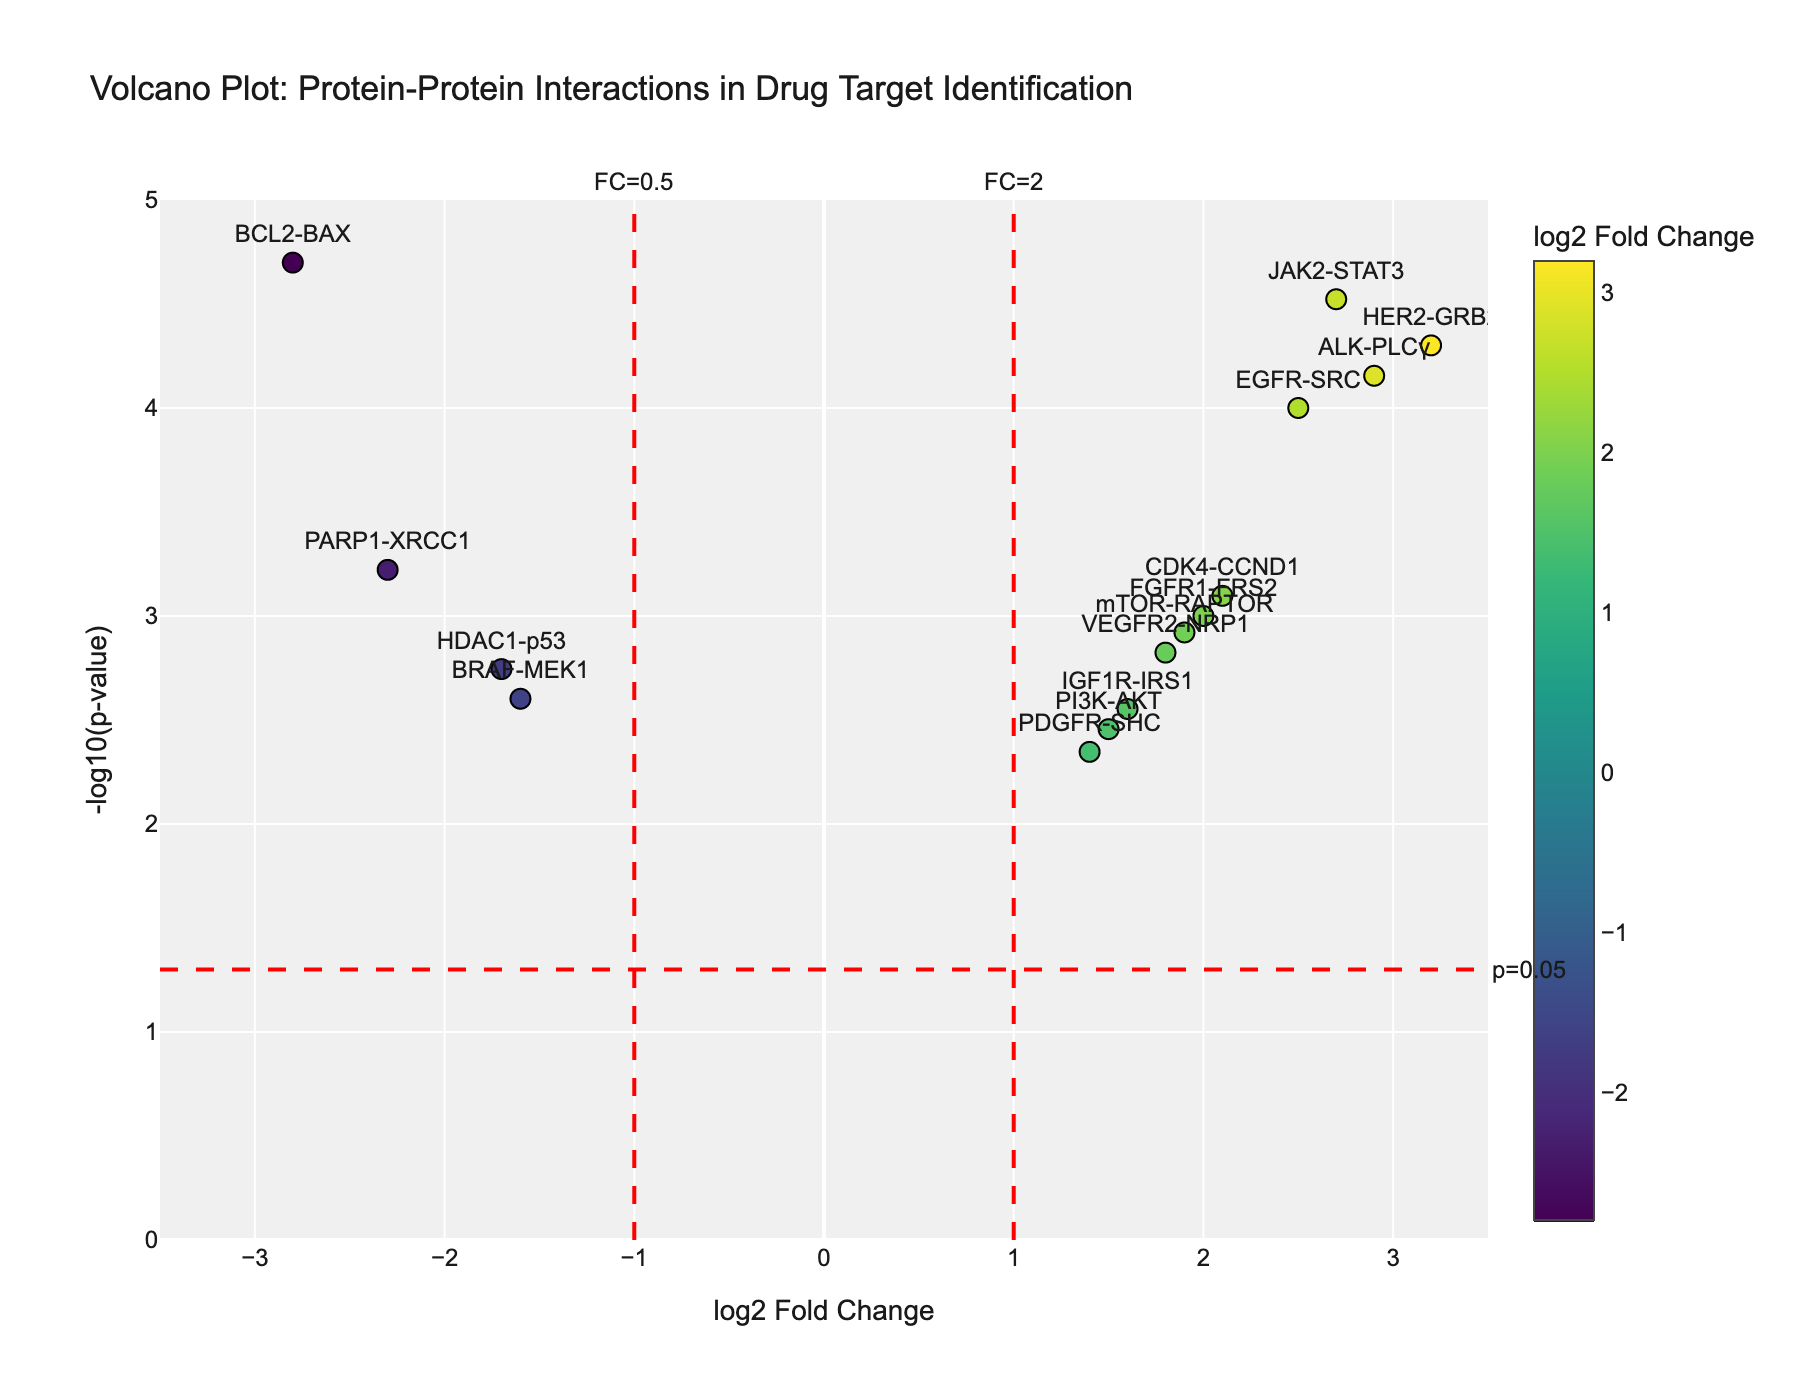How many protein-protein interactions are plotted on the Volcano Plot? By counting the number of data points (markers) on the plot, you can determine the number of protein-protein interactions.
Answer: 14 Which protein interaction has the highest log2 Fold Change? Identify the data point with the highest x-axis value, which represents log2 Fold Change. According to the dataset, HER2-GRB2 has the highest log2 Fold Change of 3.2.
Answer: HER2-GRB2 What is the p-value for the interaction between EGFR and SRC? Use the hover information of the data point associated with EGFR-SRC to find the p-value provided there. The p-value for EGFR-SRC interaction is 0.0001.
Answer: 0.0001 Among the plotted interactions, which one has the most significant p-value (i.e., the smallest p-value)? Identify the data point with the highest y-axis value, which represents the -log10(pValue). The interaction JAK2-STAT3 has the most significant p-value, as indicated by its highest position on the y-axis.
Answer: JAK2-STAT3 Compare the log2 Fold Change between the BRAF-MEK1 and PARP1-XRCC1 interactions. Which is more negative? Locate the x-axis values (log2 Fold Change) for BRAF-MEK1 and PARP1-XRCC1 and compare them. BRAF-MEK1 has a log2 Fold Change of -1.6 and PARP1-XRCC1 has -2.3, so PARP1-XRCC1 is more negative.
Answer: PARP1-XRCC1 How many interactions have a log2 Fold Change greater than 2 and a p-value less than 0.001? Identify the data points that fall to the right of the vertical line at x=2 and above the horizontal line at y=-log10(0.001). These interactions are HER2-GRB2, JAK2-STAT3, and ALK-PLCγ, totaling 3 interactions.
Answer: 3 Are there any interactions with a log2 Fold Change less than -2? If so, name them. Identify data points with x-axis values less than -2. The one such interaction is BCL2-BAX with a log2 Fold Change of -2.8.
Answer: BCL2-BAX What is the approximate range of -log10(p-values) on the y-axis? Determine the lowest and highest y-axis values represented by the data points. The range is from approximately 0 (for higher p-values) to about 5 (for the most significant p-values).
Answer: 0 to 5 Which interaction has a log2 Fold Change closest to 2.0 with a significant p-value? Identify the data point with an x-axis value closest to 2.0 and verify if its y-axis value indicates a significant p-value (higher y-value). The interaction FGFR1-FRS2 fits these criteria.
Answer: FGFR1-FRS2 